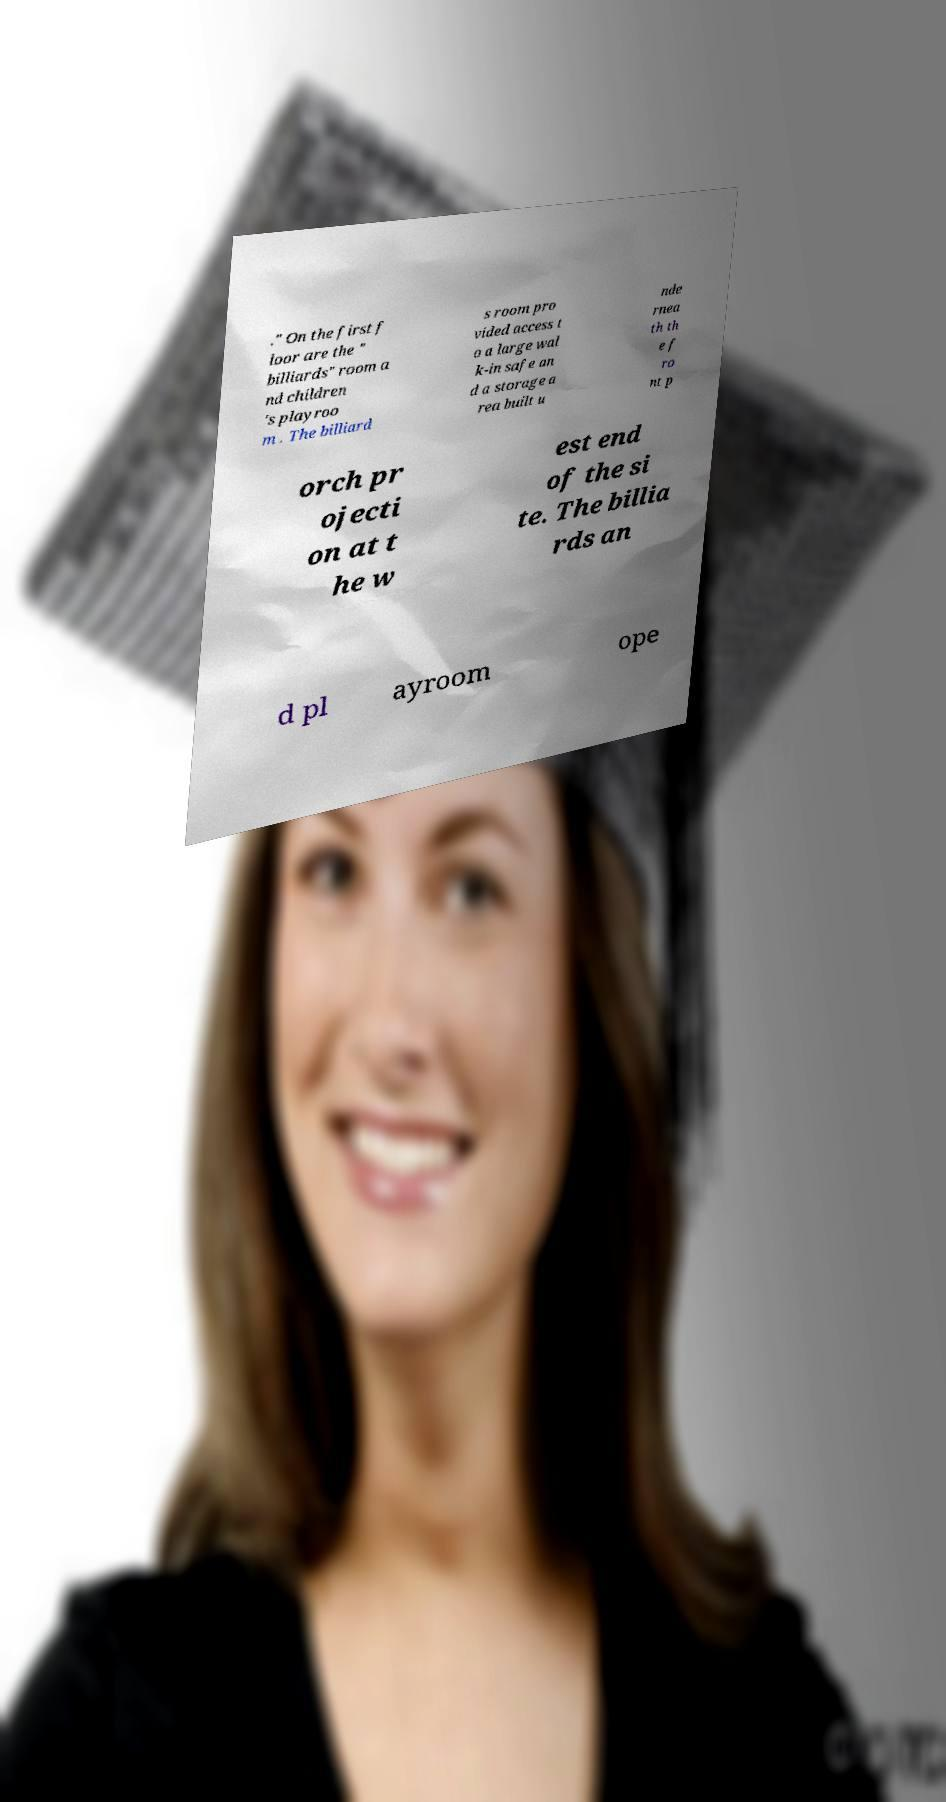Could you assist in decoding the text presented in this image and type it out clearly? ." On the first f loor are the " billiards" room a nd children 's playroo m . The billiard s room pro vided access t o a large wal k-in safe an d a storage a rea built u nde rnea th th e f ro nt p orch pr ojecti on at t he w est end of the si te. The billia rds an d pl ayroom ope 